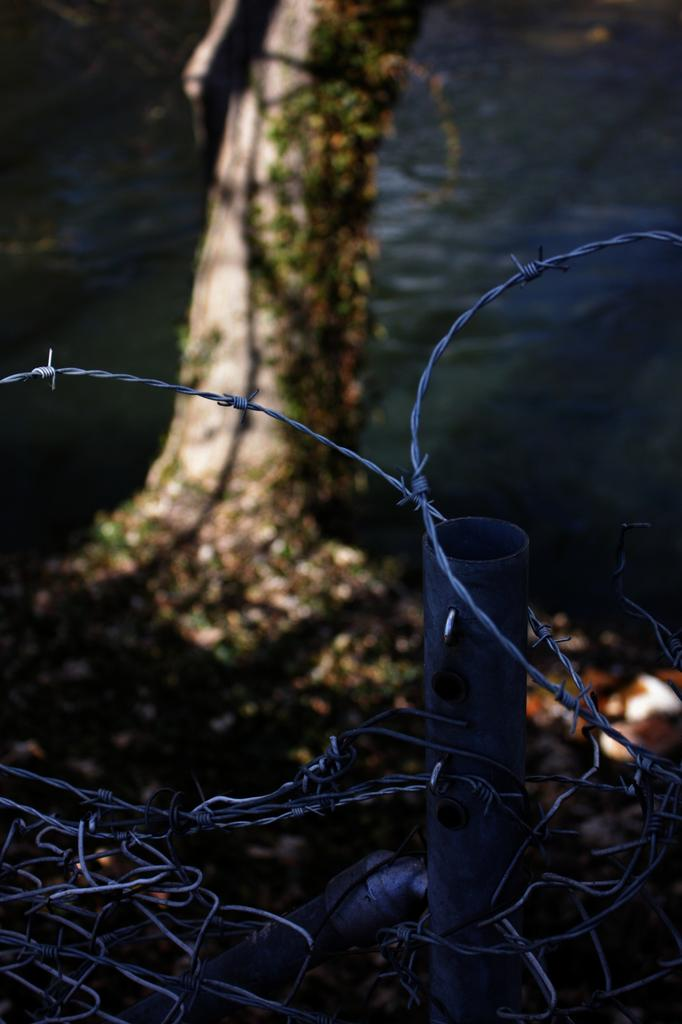What is located in the foreground of the image? There is a fence in the foreground of the image. What can be seen at the back of the image? There is a tree at the back of the image. What natural element is visible at the bottom of the image? There is water visible at the bottom of the image. How does the fence compare to an expert in the image? There is no comparison being made between the fence and an expert in the image, as the image only contains a fence, a tree, and water. 